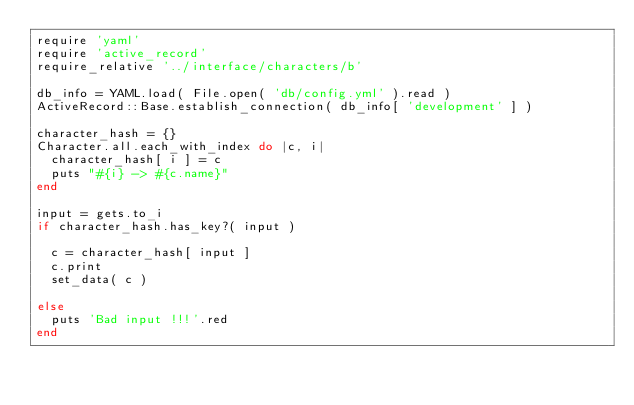Convert code to text. <code><loc_0><loc_0><loc_500><loc_500><_Ruby_>require 'yaml'
require 'active_record'
require_relative '../interface/characters/b'

db_info = YAML.load( File.open( 'db/config.yml' ).read )
ActiveRecord::Base.establish_connection( db_info[ 'development' ] )

character_hash = {}
Character.all.each_with_index do |c, i|
  character_hash[ i ] = c
  puts "#{i} -> #{c.name}"
end

input = gets.to_i
if character_hash.has_key?( input )

  c = character_hash[ input ]
  c.print
  set_data( c )

else
  puts 'Bad input !!!'.red
end</code> 